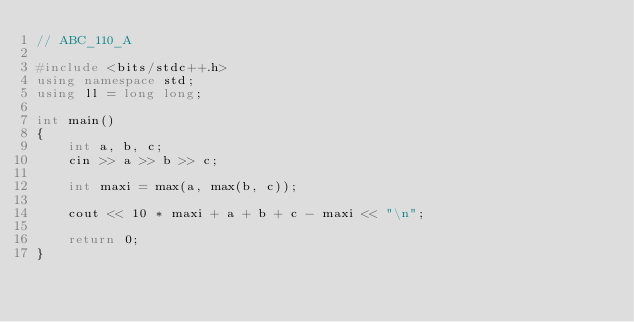Convert code to text. <code><loc_0><loc_0><loc_500><loc_500><_C++_>// ABC_110_A

#include <bits/stdc++.h>
using namespace std;
using ll = long long;

int main()
{
	int a, b, c;
	cin >> a >> b >> c;

	int maxi = max(a, max(b, c));

	cout << 10 * maxi + a + b + c - maxi << "\n";

	return 0;
}
</code> 